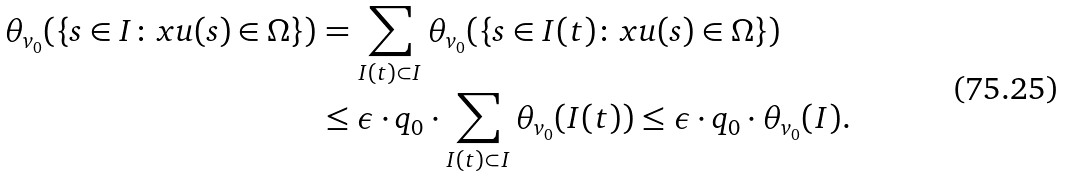Convert formula to latex. <formula><loc_0><loc_0><loc_500><loc_500>\theta _ { v _ { 0 } } ( \{ s \in I \colon x u ( s ) \in \Omega \} ) & = \sum _ { I ( t ) \subset I } \theta _ { v _ { 0 } } ( \{ s \in I ( t ) \colon x u ( s ) \in \Omega \} ) \\ & \leq \epsilon \cdot q _ { 0 } \cdot \sum _ { I ( t ) \subset I } \theta _ { v _ { 0 } } ( I ( t ) ) \leq \epsilon \cdot q _ { 0 } \cdot \theta _ { v _ { 0 } } ( I ) .</formula> 